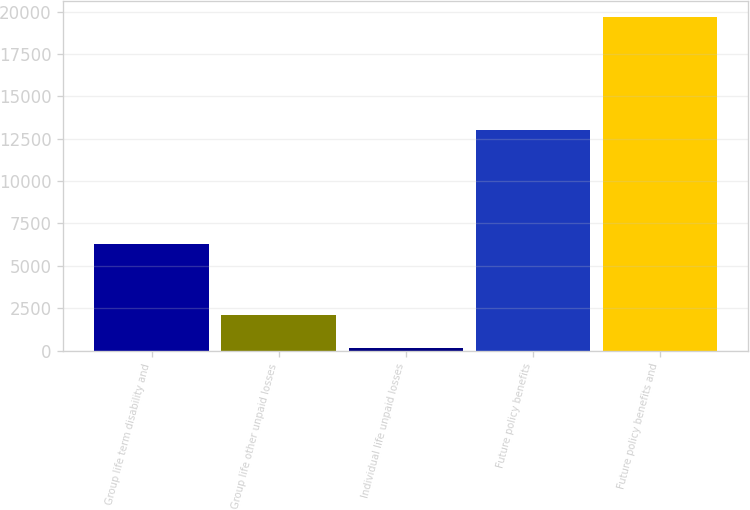Convert chart to OTSL. <chart><loc_0><loc_0><loc_500><loc_500><bar_chart><fcel>Group life term disability and<fcel>Group life other unpaid losses<fcel>Individual life unpaid losses<fcel>Future policy benefits<fcel>Future policy benefits and<nl><fcel>6308<fcel>2117.2<fcel>167<fcel>12988<fcel>19669<nl></chart> 